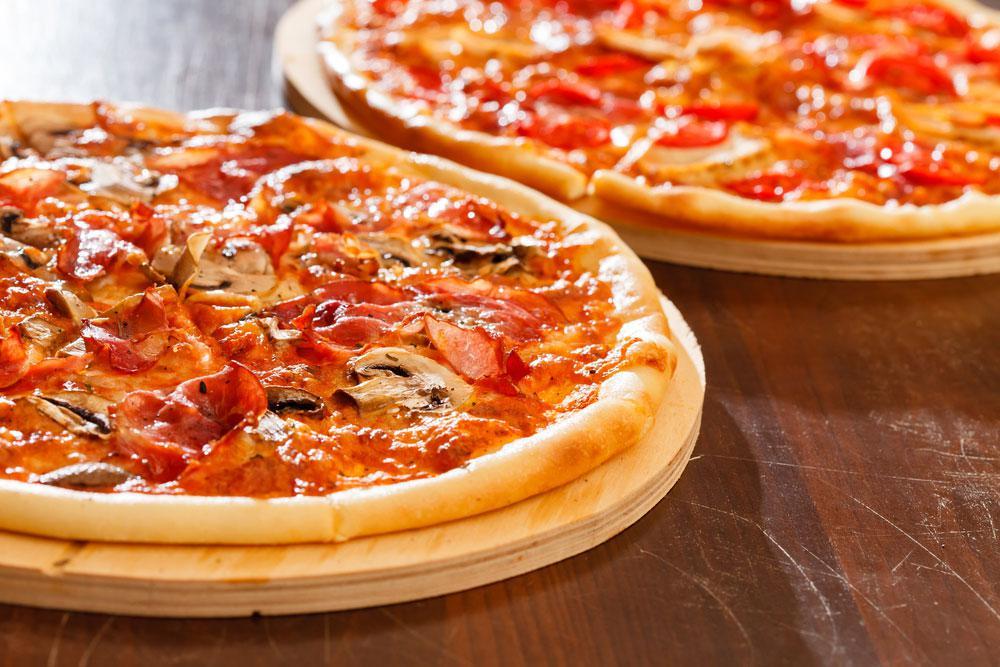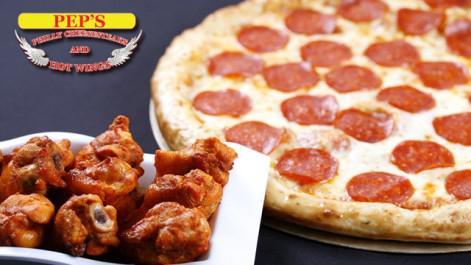The first image is the image on the left, the second image is the image on the right. For the images shown, is this caption "One image contains two pizzas and the other image contains one pizza." true? Answer yes or no. Yes. The first image is the image on the left, the second image is the image on the right. Evaluate the accuracy of this statement regarding the images: "The left and right image contains the same number of pizzas.". Is it true? Answer yes or no. No. 